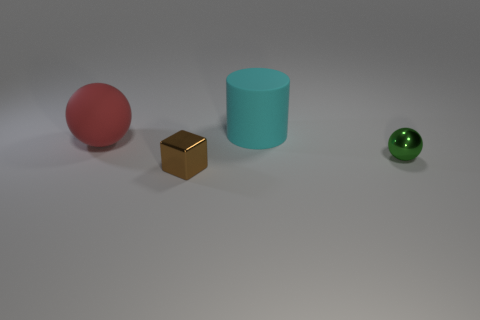Add 3 shiny objects. How many objects exist? 7 Subtract 1 balls. How many balls are left? 1 Subtract all green spheres. How many spheres are left? 1 Subtract 1 red spheres. How many objects are left? 3 Subtract all cylinders. How many objects are left? 3 Subtract all blue spheres. Subtract all cyan cylinders. How many spheres are left? 2 Subtract all cubes. Subtract all small purple rubber objects. How many objects are left? 3 Add 4 green things. How many green things are left? 5 Add 3 cyan matte blocks. How many cyan matte blocks exist? 3 